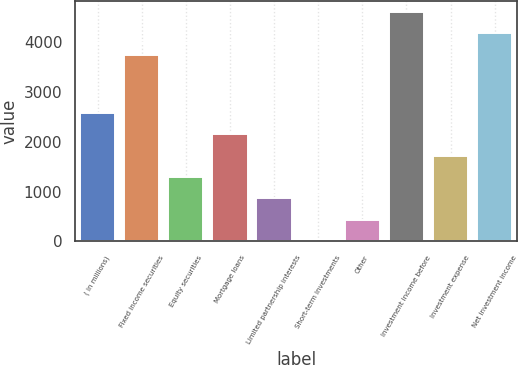Convert chart. <chart><loc_0><loc_0><loc_500><loc_500><bar_chart><fcel>( in millions)<fcel>Fixed income securities<fcel>Equity securities<fcel>Mortgage loans<fcel>Limited partnership interests<fcel>Short-term investments<fcel>Other<fcel>Investment income before<fcel>Investment expense<fcel>Net investment income<nl><fcel>2570.6<fcel>3737<fcel>1289.3<fcel>2143.5<fcel>862.2<fcel>8<fcel>435.1<fcel>4591.2<fcel>1716.4<fcel>4164.1<nl></chart> 